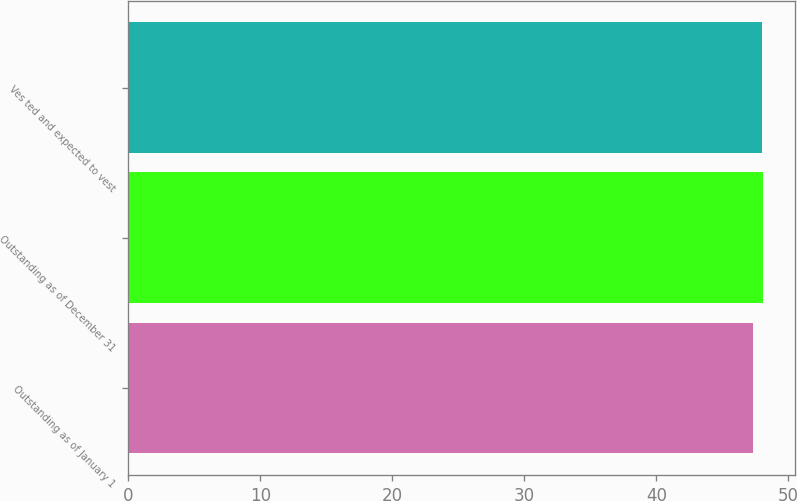<chart> <loc_0><loc_0><loc_500><loc_500><bar_chart><fcel>Outstanding as of January 1<fcel>Outstanding as of December 31<fcel>Ves ted and expected to vest<nl><fcel>47.35<fcel>48.08<fcel>48.01<nl></chart> 